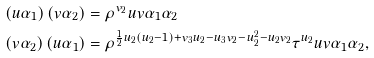<formula> <loc_0><loc_0><loc_500><loc_500>\left ( u \alpha _ { 1 } \right ) \left ( v \alpha _ { 2 } \right ) & = \rho ^ { v _ { 2 } } u v \alpha _ { 1 } \alpha _ { 2 } \ \\ \left ( v \alpha _ { 2 } \right ) \left ( u \alpha _ { 1 } \right ) & = \rho ^ { \frac { 1 } { 2 } u _ { 2 } \left ( u _ { 2 } - 1 \right ) + v _ { 3 } u _ { 2 } - u _ { 3 } v _ { 2 } - u _ { 2 } ^ { 2 } - u _ { 2 } v _ { 2 } } \tau ^ { u _ { 2 } } u v \alpha _ { 1 } \alpha _ { 2 } ,</formula> 